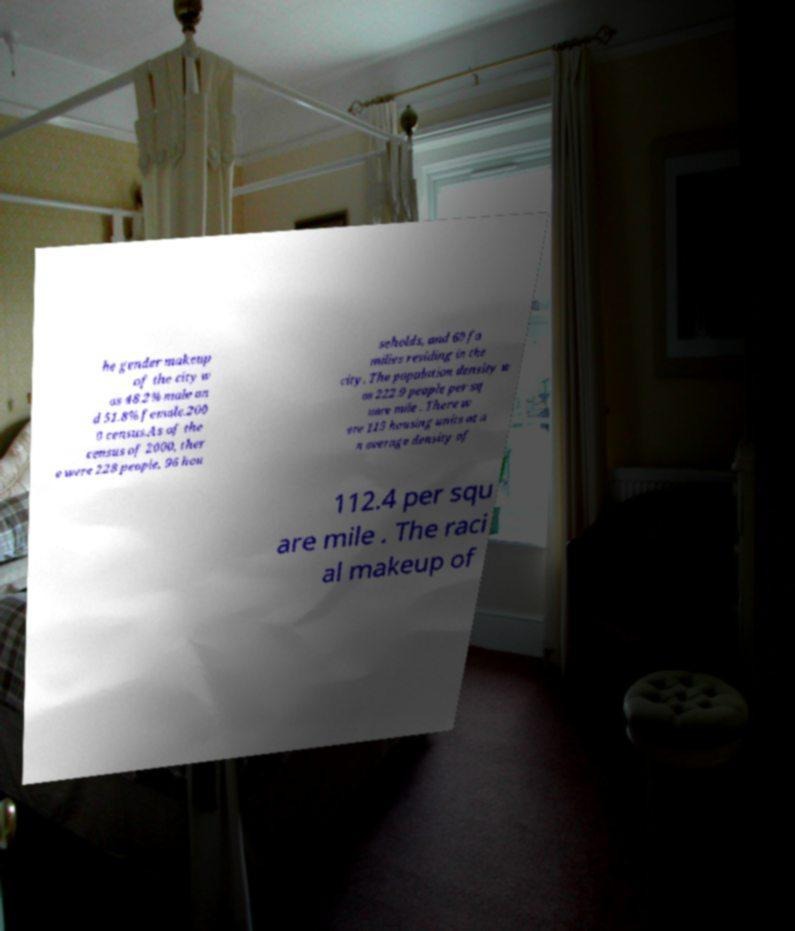What messages or text are displayed in this image? I need them in a readable, typed format. he gender makeup of the city w as 48.2% male an d 51.8% female.200 0 census.As of the census of 2000, ther e were 228 people, 96 hou seholds, and 60 fa milies residing in the city. The population density w as 222.9 people per sq uare mile . There w ere 115 housing units at a n average density of 112.4 per squ are mile . The raci al makeup of 